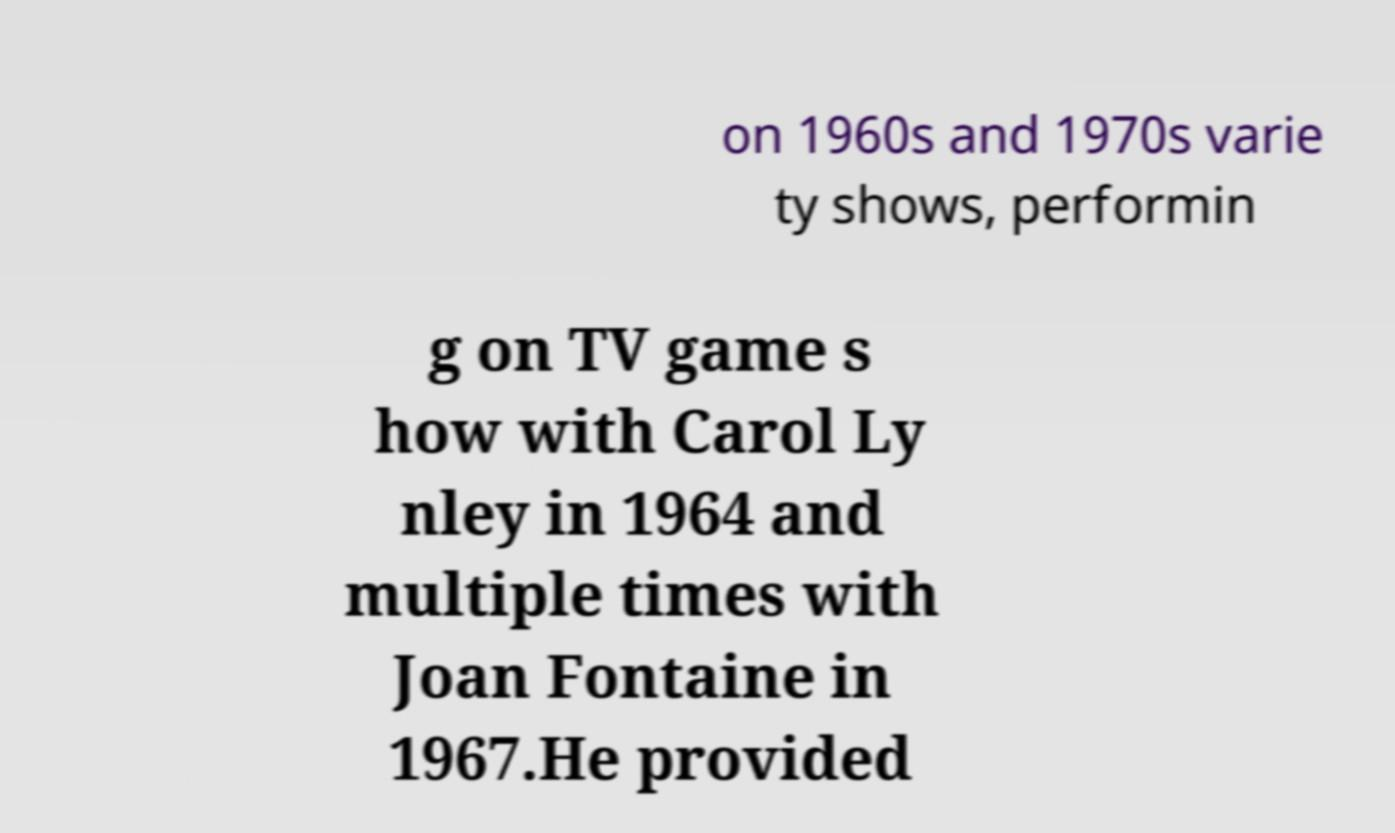For documentation purposes, I need the text within this image transcribed. Could you provide that? on 1960s and 1970s varie ty shows, performin g on TV game s how with Carol Ly nley in 1964 and multiple times with Joan Fontaine in 1967.He provided 